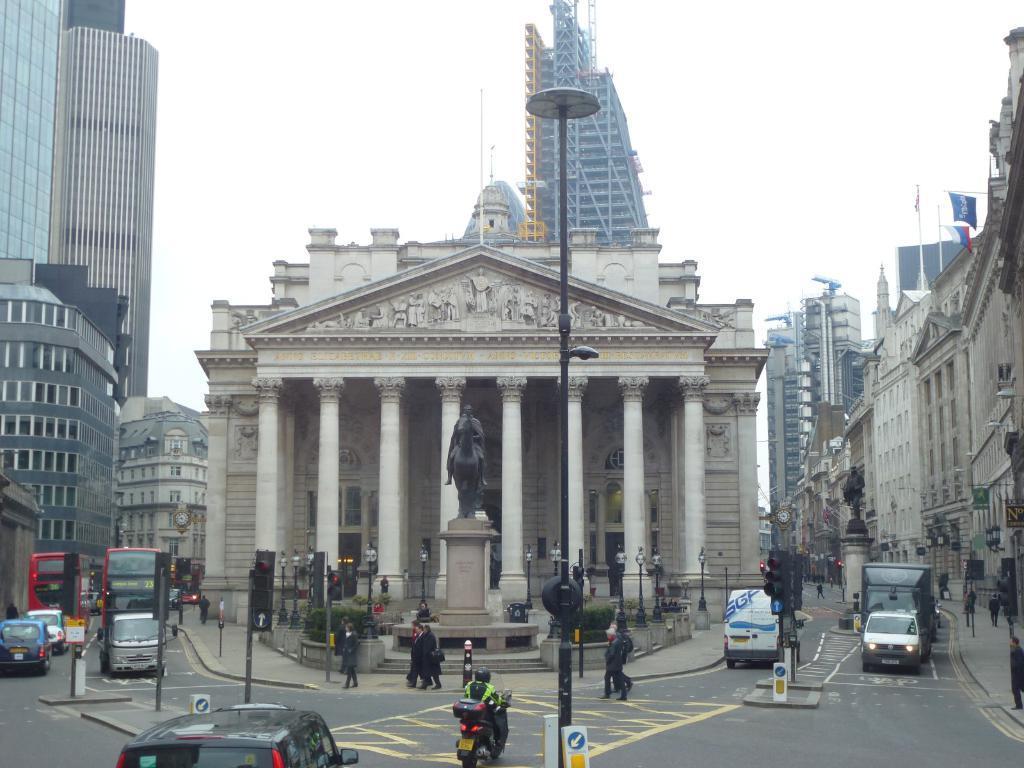Can you describe this image briefly? In this image we can see many buildings. There are few flags at the right side of the image. There are many street lights in the image. There are many vehicles in the image. There are few people in walking on the road and few people walking on the footpath. There are few boards in the image. We can see two clocks in the image. We can see the sky in the image. There are few plants in the image. There are few traffic signal lights in the image. 